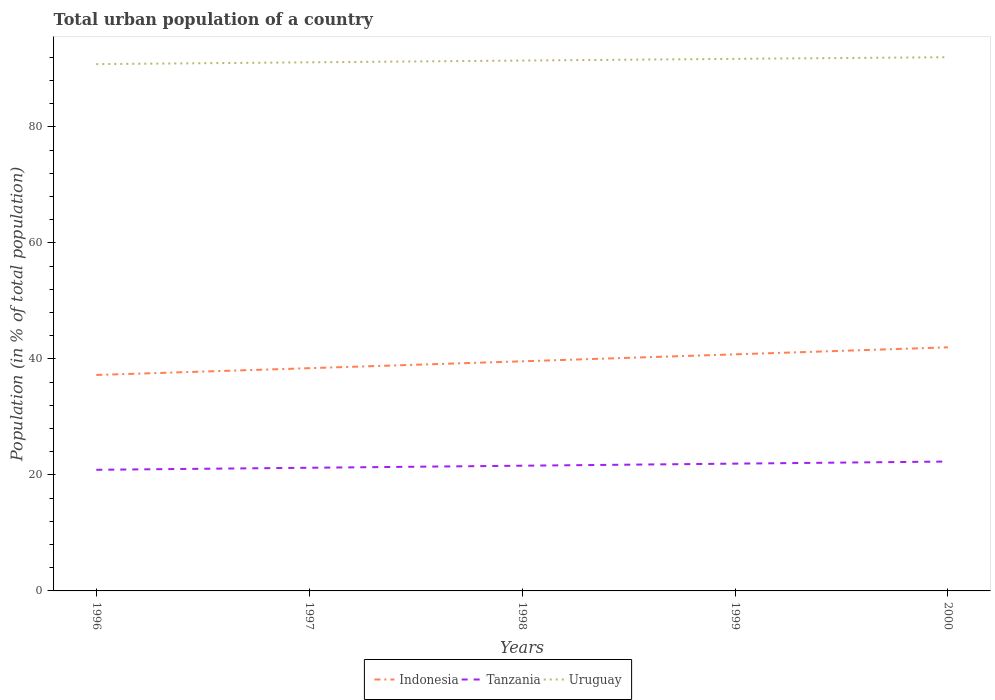How many different coloured lines are there?
Keep it short and to the point. 3. Does the line corresponding to Indonesia intersect with the line corresponding to Tanzania?
Your answer should be very brief. No. Across all years, what is the maximum urban population in Uruguay?
Offer a terse response. 90.83. In which year was the urban population in Indonesia maximum?
Your answer should be compact. 1996. What is the total urban population in Uruguay in the graph?
Give a very brief answer. -0.3. What is the difference between the highest and the second highest urban population in Tanzania?
Your answer should be very brief. 1.42. What is the difference between the highest and the lowest urban population in Indonesia?
Your answer should be compact. 2. Is the urban population in Indonesia strictly greater than the urban population in Uruguay over the years?
Provide a short and direct response. Yes. How many years are there in the graph?
Offer a very short reply. 5. What is the difference between two consecutive major ticks on the Y-axis?
Provide a short and direct response. 20. Are the values on the major ticks of Y-axis written in scientific E-notation?
Your response must be concise. No. Does the graph contain any zero values?
Give a very brief answer. No. How many legend labels are there?
Give a very brief answer. 3. What is the title of the graph?
Ensure brevity in your answer.  Total urban population of a country. Does "Denmark" appear as one of the legend labels in the graph?
Ensure brevity in your answer.  No. What is the label or title of the Y-axis?
Make the answer very short. Population (in % of total population). What is the Population (in % of total population) of Indonesia in 1996?
Your answer should be compact. 37.23. What is the Population (in % of total population) in Tanzania in 1996?
Provide a succinct answer. 20.89. What is the Population (in % of total population) in Uruguay in 1996?
Offer a very short reply. 90.83. What is the Population (in % of total population) of Indonesia in 1997?
Provide a succinct answer. 38.41. What is the Population (in % of total population) in Tanzania in 1997?
Ensure brevity in your answer.  21.24. What is the Population (in % of total population) in Uruguay in 1997?
Offer a very short reply. 91.15. What is the Population (in % of total population) of Indonesia in 1998?
Provide a succinct answer. 39.59. What is the Population (in % of total population) in Tanzania in 1998?
Keep it short and to the point. 21.59. What is the Population (in % of total population) of Uruguay in 1998?
Your response must be concise. 91.45. What is the Population (in % of total population) of Indonesia in 1999?
Your answer should be very brief. 40.79. What is the Population (in % of total population) of Tanzania in 1999?
Provide a short and direct response. 21.95. What is the Population (in % of total population) of Uruguay in 1999?
Make the answer very short. 91.74. What is the Population (in % of total population) of Indonesia in 2000?
Give a very brief answer. 42. What is the Population (in % of total population) of Tanzania in 2000?
Your answer should be compact. 22.31. What is the Population (in % of total population) in Uruguay in 2000?
Offer a terse response. 92.03. Across all years, what is the maximum Population (in % of total population) in Indonesia?
Offer a terse response. 42. Across all years, what is the maximum Population (in % of total population) in Tanzania?
Make the answer very short. 22.31. Across all years, what is the maximum Population (in % of total population) in Uruguay?
Your answer should be very brief. 92.03. Across all years, what is the minimum Population (in % of total population) in Indonesia?
Ensure brevity in your answer.  37.23. Across all years, what is the minimum Population (in % of total population) of Tanzania?
Make the answer very short. 20.89. Across all years, what is the minimum Population (in % of total population) of Uruguay?
Ensure brevity in your answer.  90.83. What is the total Population (in % of total population) of Indonesia in the graph?
Your response must be concise. 198.03. What is the total Population (in % of total population) in Tanzania in the graph?
Your answer should be very brief. 107.97. What is the total Population (in % of total population) in Uruguay in the graph?
Your answer should be very brief. 457.2. What is the difference between the Population (in % of total population) of Indonesia in 1996 and that in 1997?
Make the answer very short. -1.17. What is the difference between the Population (in % of total population) in Tanzania in 1996 and that in 1997?
Ensure brevity in your answer.  -0.35. What is the difference between the Population (in % of total population) of Uruguay in 1996 and that in 1997?
Provide a short and direct response. -0.31. What is the difference between the Population (in % of total population) of Indonesia in 1996 and that in 1998?
Provide a short and direct response. -2.36. What is the difference between the Population (in % of total population) of Tanzania in 1996 and that in 1998?
Provide a short and direct response. -0.7. What is the difference between the Population (in % of total population) in Uruguay in 1996 and that in 1998?
Make the answer very short. -0.61. What is the difference between the Population (in % of total population) of Indonesia in 1996 and that in 1999?
Your response must be concise. -3.56. What is the difference between the Population (in % of total population) in Tanzania in 1996 and that in 1999?
Make the answer very short. -1.06. What is the difference between the Population (in % of total population) in Uruguay in 1996 and that in 1999?
Provide a short and direct response. -0.91. What is the difference between the Population (in % of total population) in Indonesia in 1996 and that in 2000?
Your answer should be compact. -4.77. What is the difference between the Population (in % of total population) in Tanzania in 1996 and that in 2000?
Make the answer very short. -1.42. What is the difference between the Population (in % of total population) in Uruguay in 1996 and that in 2000?
Your answer should be very brief. -1.19. What is the difference between the Population (in % of total population) of Indonesia in 1997 and that in 1998?
Provide a succinct answer. -1.19. What is the difference between the Population (in % of total population) of Tanzania in 1997 and that in 1998?
Provide a succinct answer. -0.35. What is the difference between the Population (in % of total population) in Uruguay in 1997 and that in 1998?
Provide a short and direct response. -0.3. What is the difference between the Population (in % of total population) in Indonesia in 1997 and that in 1999?
Keep it short and to the point. -2.39. What is the difference between the Population (in % of total population) in Tanzania in 1997 and that in 1999?
Provide a short and direct response. -0.71. What is the difference between the Population (in % of total population) of Uruguay in 1997 and that in 1999?
Ensure brevity in your answer.  -0.6. What is the difference between the Population (in % of total population) in Indonesia in 1997 and that in 2000?
Your answer should be compact. -3.6. What is the difference between the Population (in % of total population) of Tanzania in 1997 and that in 2000?
Give a very brief answer. -1.07. What is the difference between the Population (in % of total population) of Uruguay in 1997 and that in 2000?
Provide a short and direct response. -0.88. What is the difference between the Population (in % of total population) of Indonesia in 1998 and that in 1999?
Your answer should be compact. -1.2. What is the difference between the Population (in % of total population) in Tanzania in 1998 and that in 1999?
Provide a short and direct response. -0.36. What is the difference between the Population (in % of total population) of Uruguay in 1998 and that in 1999?
Offer a very short reply. -0.29. What is the difference between the Population (in % of total population) in Indonesia in 1998 and that in 2000?
Ensure brevity in your answer.  -2.41. What is the difference between the Population (in % of total population) of Tanzania in 1998 and that in 2000?
Your answer should be very brief. -0.72. What is the difference between the Population (in % of total population) of Uruguay in 1998 and that in 2000?
Offer a very short reply. -0.58. What is the difference between the Population (in % of total population) in Indonesia in 1999 and that in 2000?
Provide a short and direct response. -1.21. What is the difference between the Population (in % of total population) of Tanzania in 1999 and that in 2000?
Ensure brevity in your answer.  -0.36. What is the difference between the Population (in % of total population) of Uruguay in 1999 and that in 2000?
Give a very brief answer. -0.28. What is the difference between the Population (in % of total population) of Indonesia in 1996 and the Population (in % of total population) of Tanzania in 1997?
Make the answer very short. 16. What is the difference between the Population (in % of total population) in Indonesia in 1996 and the Population (in % of total population) in Uruguay in 1997?
Offer a very short reply. -53.91. What is the difference between the Population (in % of total population) in Tanzania in 1996 and the Population (in % of total population) in Uruguay in 1997?
Provide a succinct answer. -70.26. What is the difference between the Population (in % of total population) of Indonesia in 1996 and the Population (in % of total population) of Tanzania in 1998?
Your response must be concise. 15.64. What is the difference between the Population (in % of total population) of Indonesia in 1996 and the Population (in % of total population) of Uruguay in 1998?
Provide a succinct answer. -54.22. What is the difference between the Population (in % of total population) in Tanzania in 1996 and the Population (in % of total population) in Uruguay in 1998?
Your answer should be very brief. -70.56. What is the difference between the Population (in % of total population) in Indonesia in 1996 and the Population (in % of total population) in Tanzania in 1999?
Your answer should be compact. 15.29. What is the difference between the Population (in % of total population) of Indonesia in 1996 and the Population (in % of total population) of Uruguay in 1999?
Your answer should be very brief. -54.51. What is the difference between the Population (in % of total population) in Tanzania in 1996 and the Population (in % of total population) in Uruguay in 1999?
Provide a succinct answer. -70.86. What is the difference between the Population (in % of total population) of Indonesia in 1996 and the Population (in % of total population) of Tanzania in 2000?
Give a very brief answer. 14.93. What is the difference between the Population (in % of total population) of Indonesia in 1996 and the Population (in % of total population) of Uruguay in 2000?
Offer a very short reply. -54.79. What is the difference between the Population (in % of total population) in Tanzania in 1996 and the Population (in % of total population) in Uruguay in 2000?
Offer a terse response. -71.14. What is the difference between the Population (in % of total population) of Indonesia in 1997 and the Population (in % of total population) of Tanzania in 1998?
Ensure brevity in your answer.  16.82. What is the difference between the Population (in % of total population) in Indonesia in 1997 and the Population (in % of total population) in Uruguay in 1998?
Your answer should be very brief. -53.04. What is the difference between the Population (in % of total population) of Tanzania in 1997 and the Population (in % of total population) of Uruguay in 1998?
Your response must be concise. -70.21. What is the difference between the Population (in % of total population) of Indonesia in 1997 and the Population (in % of total population) of Tanzania in 1999?
Keep it short and to the point. 16.46. What is the difference between the Population (in % of total population) of Indonesia in 1997 and the Population (in % of total population) of Uruguay in 1999?
Ensure brevity in your answer.  -53.34. What is the difference between the Population (in % of total population) of Tanzania in 1997 and the Population (in % of total population) of Uruguay in 1999?
Give a very brief answer. -70.51. What is the difference between the Population (in % of total population) in Indonesia in 1997 and the Population (in % of total population) in Tanzania in 2000?
Offer a very short reply. 16.1. What is the difference between the Population (in % of total population) in Indonesia in 1997 and the Population (in % of total population) in Uruguay in 2000?
Your answer should be very brief. -53.62. What is the difference between the Population (in % of total population) in Tanzania in 1997 and the Population (in % of total population) in Uruguay in 2000?
Your answer should be compact. -70.79. What is the difference between the Population (in % of total population) of Indonesia in 1998 and the Population (in % of total population) of Tanzania in 1999?
Offer a very short reply. 17.65. What is the difference between the Population (in % of total population) of Indonesia in 1998 and the Population (in % of total population) of Uruguay in 1999?
Give a very brief answer. -52.15. What is the difference between the Population (in % of total population) in Tanzania in 1998 and the Population (in % of total population) in Uruguay in 1999?
Ensure brevity in your answer.  -70.15. What is the difference between the Population (in % of total population) of Indonesia in 1998 and the Population (in % of total population) of Tanzania in 2000?
Your answer should be very brief. 17.28. What is the difference between the Population (in % of total population) of Indonesia in 1998 and the Population (in % of total population) of Uruguay in 2000?
Your answer should be compact. -52.44. What is the difference between the Population (in % of total population) in Tanzania in 1998 and the Population (in % of total population) in Uruguay in 2000?
Your response must be concise. -70.44. What is the difference between the Population (in % of total population) of Indonesia in 1999 and the Population (in % of total population) of Tanzania in 2000?
Give a very brief answer. 18.48. What is the difference between the Population (in % of total population) in Indonesia in 1999 and the Population (in % of total population) in Uruguay in 2000?
Make the answer very short. -51.24. What is the difference between the Population (in % of total population) in Tanzania in 1999 and the Population (in % of total population) in Uruguay in 2000?
Make the answer very short. -70.08. What is the average Population (in % of total population) of Indonesia per year?
Give a very brief answer. 39.61. What is the average Population (in % of total population) of Tanzania per year?
Your response must be concise. 21.59. What is the average Population (in % of total population) of Uruguay per year?
Offer a terse response. 91.44. In the year 1996, what is the difference between the Population (in % of total population) in Indonesia and Population (in % of total population) in Tanzania?
Offer a terse response. 16.35. In the year 1996, what is the difference between the Population (in % of total population) of Indonesia and Population (in % of total population) of Uruguay?
Your answer should be very brief. -53.6. In the year 1996, what is the difference between the Population (in % of total population) in Tanzania and Population (in % of total population) in Uruguay?
Your answer should be very brief. -69.95. In the year 1997, what is the difference between the Population (in % of total population) in Indonesia and Population (in % of total population) in Tanzania?
Offer a very short reply. 17.17. In the year 1997, what is the difference between the Population (in % of total population) of Indonesia and Population (in % of total population) of Uruguay?
Make the answer very short. -52.74. In the year 1997, what is the difference between the Population (in % of total population) of Tanzania and Population (in % of total population) of Uruguay?
Ensure brevity in your answer.  -69.91. In the year 1998, what is the difference between the Population (in % of total population) of Indonesia and Population (in % of total population) of Tanzania?
Ensure brevity in your answer.  18. In the year 1998, what is the difference between the Population (in % of total population) of Indonesia and Population (in % of total population) of Uruguay?
Offer a terse response. -51.86. In the year 1998, what is the difference between the Population (in % of total population) of Tanzania and Population (in % of total population) of Uruguay?
Give a very brief answer. -69.86. In the year 1999, what is the difference between the Population (in % of total population) of Indonesia and Population (in % of total population) of Tanzania?
Keep it short and to the point. 18.84. In the year 1999, what is the difference between the Population (in % of total population) of Indonesia and Population (in % of total population) of Uruguay?
Provide a succinct answer. -50.95. In the year 1999, what is the difference between the Population (in % of total population) of Tanzania and Population (in % of total population) of Uruguay?
Provide a succinct answer. -69.8. In the year 2000, what is the difference between the Population (in % of total population) of Indonesia and Population (in % of total population) of Tanzania?
Your response must be concise. 19.69. In the year 2000, what is the difference between the Population (in % of total population) of Indonesia and Population (in % of total population) of Uruguay?
Ensure brevity in your answer.  -50.03. In the year 2000, what is the difference between the Population (in % of total population) of Tanzania and Population (in % of total population) of Uruguay?
Offer a very short reply. -69.72. What is the ratio of the Population (in % of total population) in Indonesia in 1996 to that in 1997?
Your response must be concise. 0.97. What is the ratio of the Population (in % of total population) of Tanzania in 1996 to that in 1997?
Keep it short and to the point. 0.98. What is the ratio of the Population (in % of total population) of Uruguay in 1996 to that in 1997?
Make the answer very short. 1. What is the ratio of the Population (in % of total population) in Indonesia in 1996 to that in 1998?
Offer a terse response. 0.94. What is the ratio of the Population (in % of total population) of Tanzania in 1996 to that in 1998?
Offer a terse response. 0.97. What is the ratio of the Population (in % of total population) of Uruguay in 1996 to that in 1998?
Your response must be concise. 0.99. What is the ratio of the Population (in % of total population) of Indonesia in 1996 to that in 1999?
Provide a short and direct response. 0.91. What is the ratio of the Population (in % of total population) of Tanzania in 1996 to that in 1999?
Provide a succinct answer. 0.95. What is the ratio of the Population (in % of total population) in Uruguay in 1996 to that in 1999?
Make the answer very short. 0.99. What is the ratio of the Population (in % of total population) in Indonesia in 1996 to that in 2000?
Your answer should be compact. 0.89. What is the ratio of the Population (in % of total population) of Tanzania in 1996 to that in 2000?
Your response must be concise. 0.94. What is the ratio of the Population (in % of total population) in Uruguay in 1996 to that in 2000?
Your answer should be very brief. 0.99. What is the ratio of the Population (in % of total population) of Indonesia in 1997 to that in 1998?
Your answer should be very brief. 0.97. What is the ratio of the Population (in % of total population) in Tanzania in 1997 to that in 1998?
Your answer should be compact. 0.98. What is the ratio of the Population (in % of total population) of Indonesia in 1997 to that in 1999?
Offer a very short reply. 0.94. What is the ratio of the Population (in % of total population) of Tanzania in 1997 to that in 1999?
Ensure brevity in your answer.  0.97. What is the ratio of the Population (in % of total population) of Uruguay in 1997 to that in 1999?
Provide a short and direct response. 0.99. What is the ratio of the Population (in % of total population) in Indonesia in 1997 to that in 2000?
Provide a short and direct response. 0.91. What is the ratio of the Population (in % of total population) of Tanzania in 1997 to that in 2000?
Offer a very short reply. 0.95. What is the ratio of the Population (in % of total population) in Uruguay in 1997 to that in 2000?
Keep it short and to the point. 0.99. What is the ratio of the Population (in % of total population) in Indonesia in 1998 to that in 1999?
Offer a very short reply. 0.97. What is the ratio of the Population (in % of total population) of Tanzania in 1998 to that in 1999?
Make the answer very short. 0.98. What is the ratio of the Population (in % of total population) in Indonesia in 1998 to that in 2000?
Your response must be concise. 0.94. What is the ratio of the Population (in % of total population) of Tanzania in 1998 to that in 2000?
Keep it short and to the point. 0.97. What is the ratio of the Population (in % of total population) of Uruguay in 1998 to that in 2000?
Offer a terse response. 0.99. What is the ratio of the Population (in % of total population) in Indonesia in 1999 to that in 2000?
Ensure brevity in your answer.  0.97. What is the ratio of the Population (in % of total population) in Tanzania in 1999 to that in 2000?
Make the answer very short. 0.98. What is the difference between the highest and the second highest Population (in % of total population) of Indonesia?
Provide a short and direct response. 1.21. What is the difference between the highest and the second highest Population (in % of total population) of Tanzania?
Offer a terse response. 0.36. What is the difference between the highest and the second highest Population (in % of total population) in Uruguay?
Your response must be concise. 0.28. What is the difference between the highest and the lowest Population (in % of total population) in Indonesia?
Keep it short and to the point. 4.77. What is the difference between the highest and the lowest Population (in % of total population) of Tanzania?
Make the answer very short. 1.42. What is the difference between the highest and the lowest Population (in % of total population) in Uruguay?
Provide a succinct answer. 1.19. 